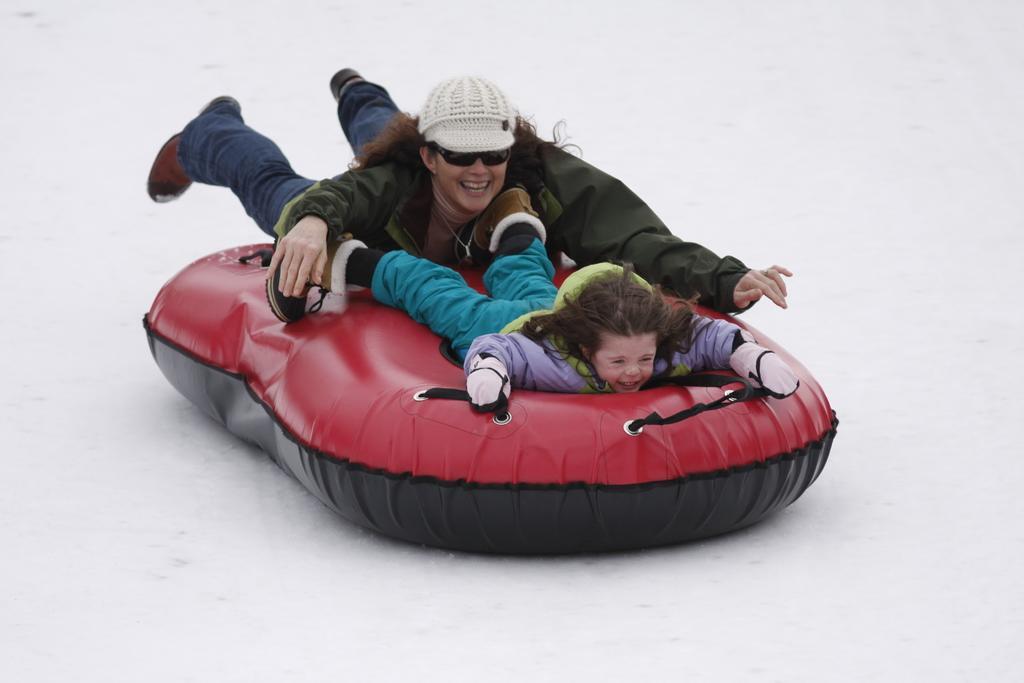How would you summarize this image in a sentence or two? In this picture there is a woman who is wearing goggles, cap, jacket, t-shirt, pocket, jeans and shoes. Beside her there is a baby girl. Both of them are lying on this tube board on the snow. 